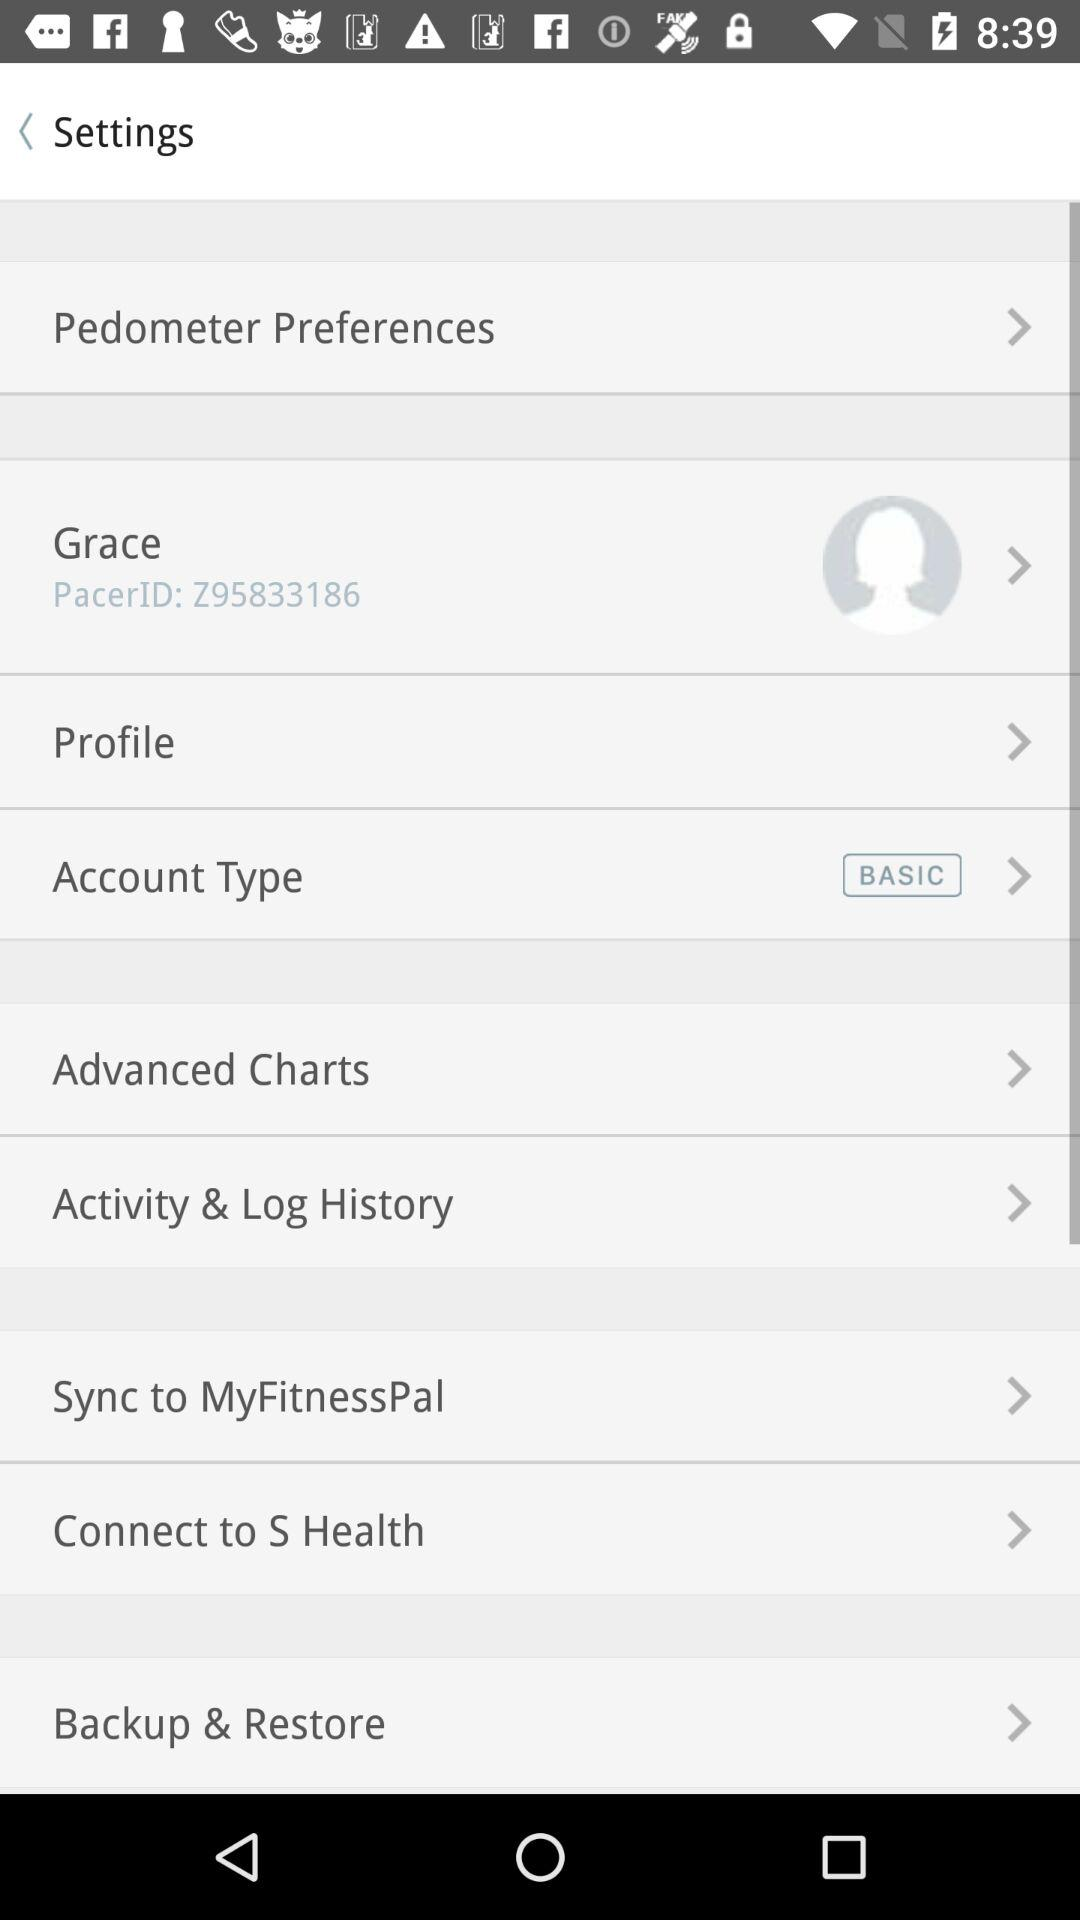What is the pacer ID? The pacer ID is Z95833186. 